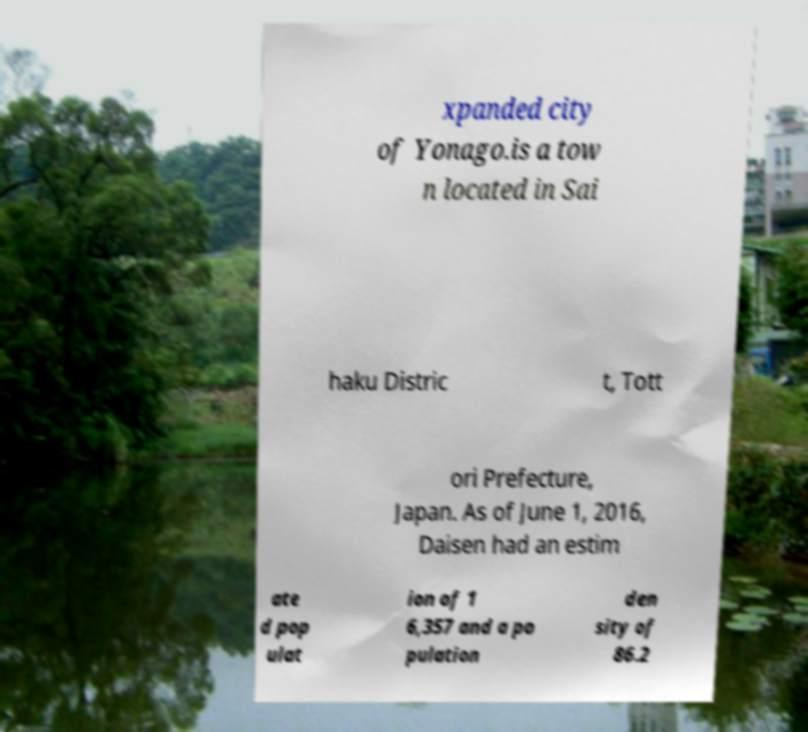Can you accurately transcribe the text from the provided image for me? xpanded city of Yonago.is a tow n located in Sai haku Distric t, Tott ori Prefecture, Japan. As of June 1, 2016, Daisen had an estim ate d pop ulat ion of 1 6,357 and a po pulation den sity of 86.2 